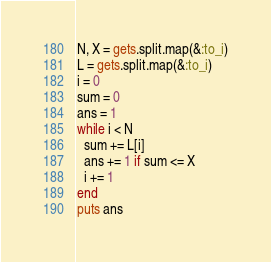<code> <loc_0><loc_0><loc_500><loc_500><_Ruby_>N, X = gets.split.map(&:to_i)
L = gets.split.map(&:to_i)
i = 0
sum = 0
ans = 1
while i < N
  sum += L[i]
  ans += 1 if sum <= X
  i += 1
end
puts ans</code> 